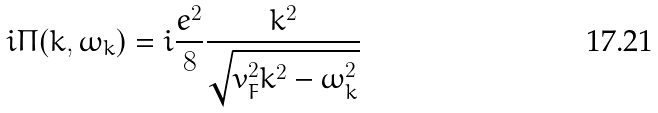Convert formula to latex. <formula><loc_0><loc_0><loc_500><loc_500>i \Pi ( { k } , \omega _ { k } ) = i \frac { e ^ { 2 } } { 8 } \frac { { k } ^ { 2 } } { \sqrt { v _ { F } ^ { 2 } { k } ^ { 2 } - \omega _ { k } ^ { 2 } } }</formula> 